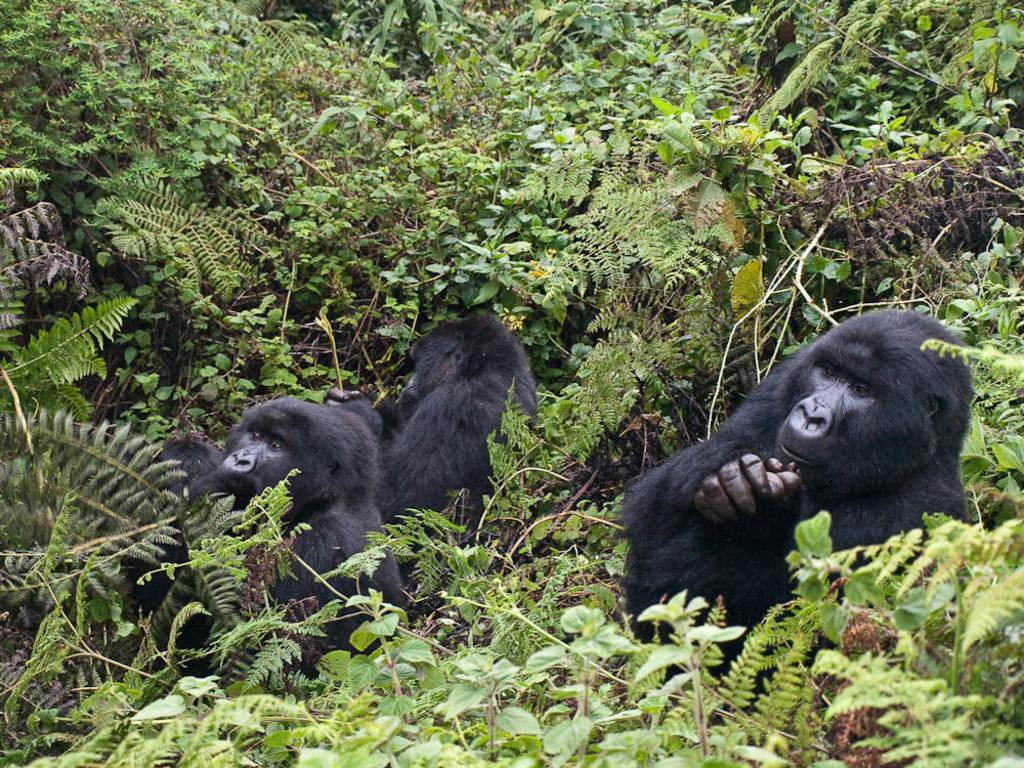Describe this image in one or two sentences. This picture might be taken from the forest. In this image, in the middle, we can see two animals. In the background, we can see some trees and plants. 